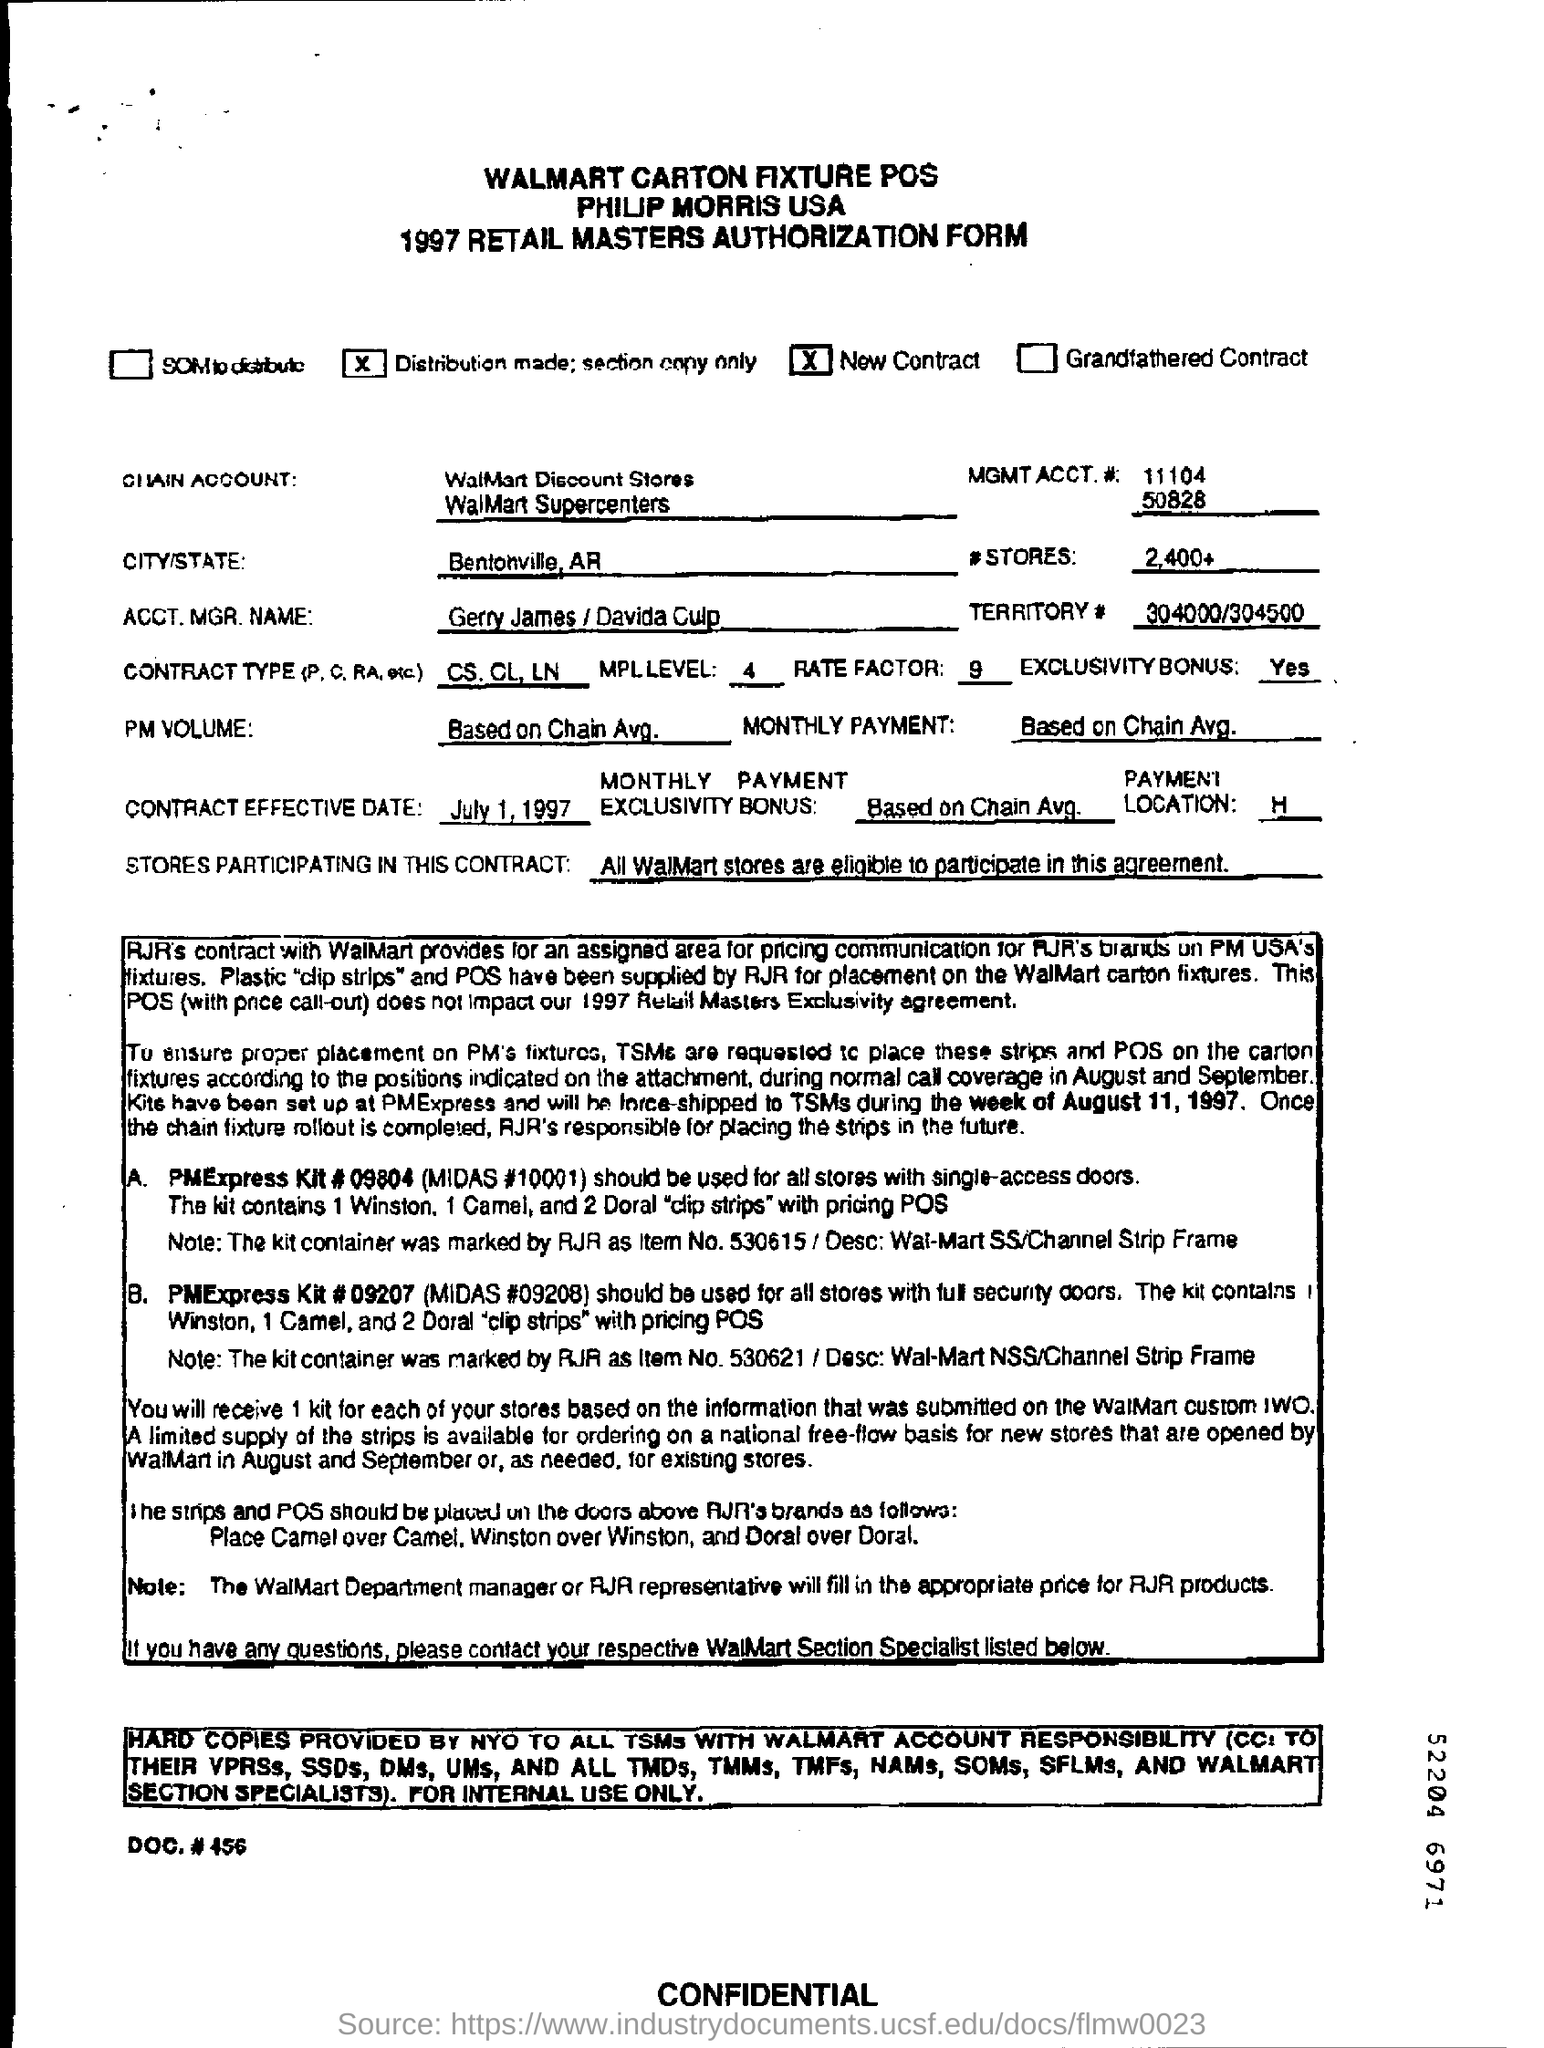What is the name of the city / state ?
Your answer should be very brief. Bentonville , AR. What is the contract type(p , c, ra , etc) ?
Provide a succinct answer. CS.CL, LN. When is the contact effective date ?
Give a very brief answer. July 1 , 1997. What is mentioned in the  territory#  ?
Ensure brevity in your answer.  304000/304500. Which stores are participating in this contract ?
Ensure brevity in your answer.  All walmart stores are eligible to participate in this agreement. What is the pm volume?
Make the answer very short. Based on chain Avg. What is the rate factor ?
Provide a short and direct response. 9. What is the mpl level
Keep it short and to the point. 4. What is mentioned in the  mgmt acct.# ?
Your response must be concise. 11104 50828. What is the name of the chain account ?
Provide a short and direct response. WalMart Discount Stores WallMart Supercenters. 